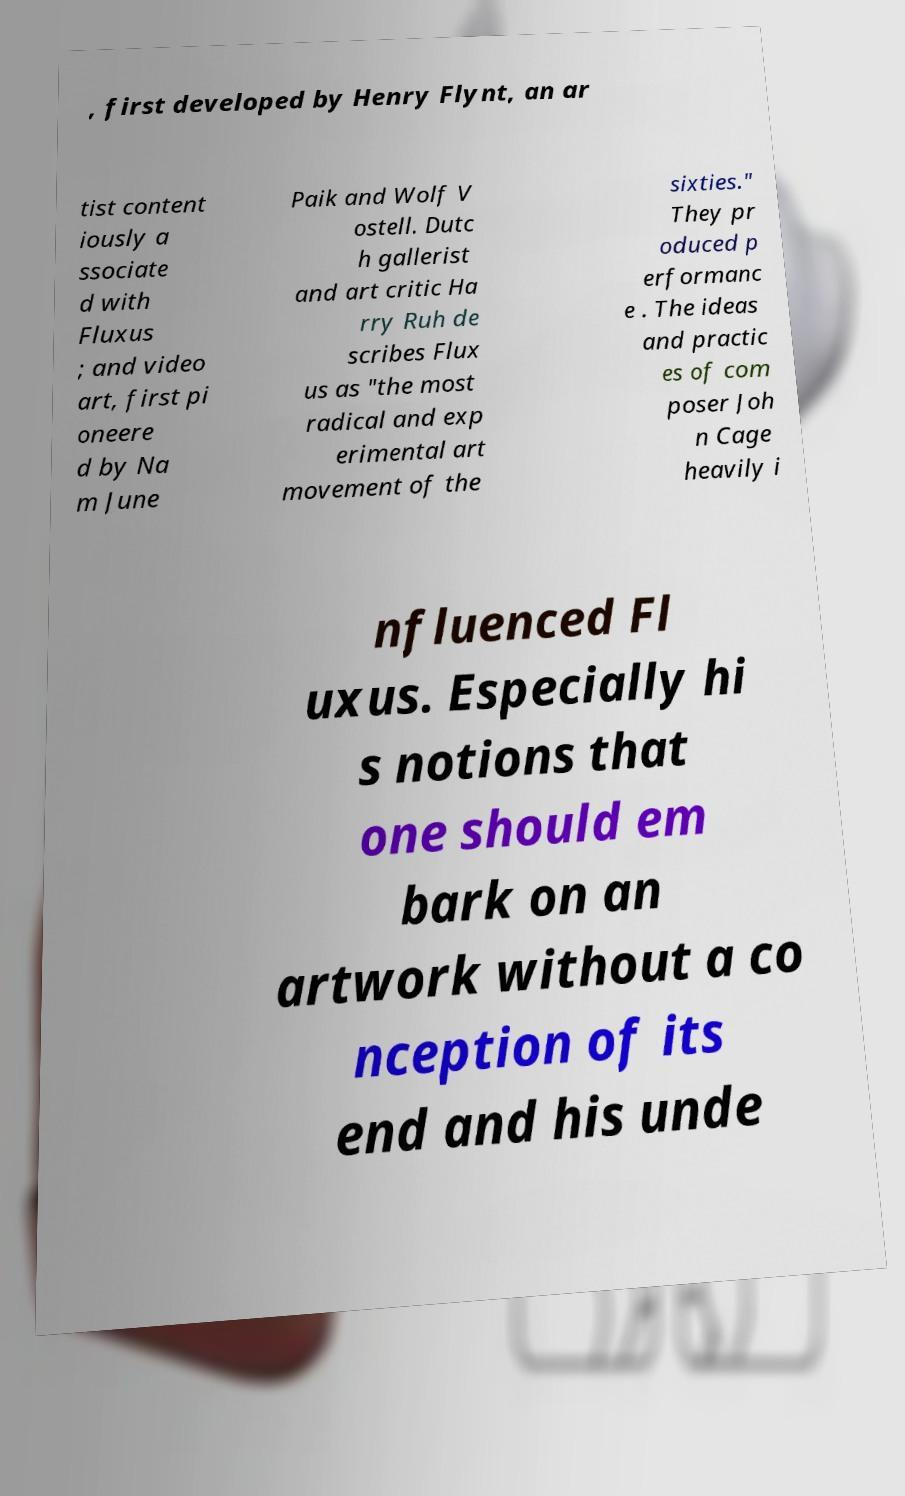Can you accurately transcribe the text from the provided image for me? , first developed by Henry Flynt, an ar tist content iously a ssociate d with Fluxus ; and video art, first pi oneere d by Na m June Paik and Wolf V ostell. Dutc h gallerist and art critic Ha rry Ruh de scribes Flux us as "the most radical and exp erimental art movement of the sixties." They pr oduced p erformanc e . The ideas and practic es of com poser Joh n Cage heavily i nfluenced Fl uxus. Especially hi s notions that one should em bark on an artwork without a co nception of its end and his unde 